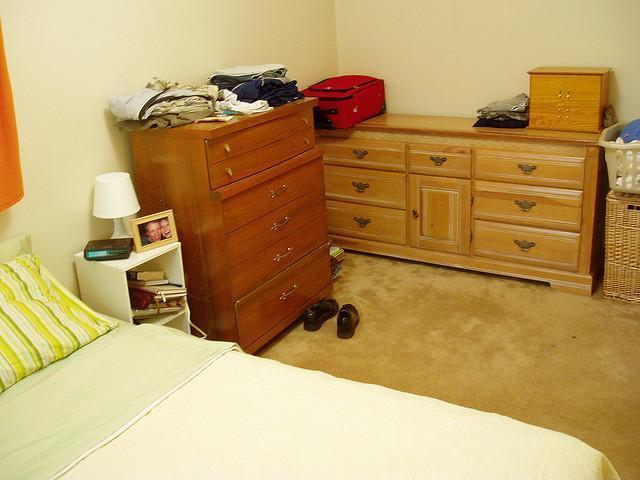How many dressers are there?
Give a very brief answer. 2. 